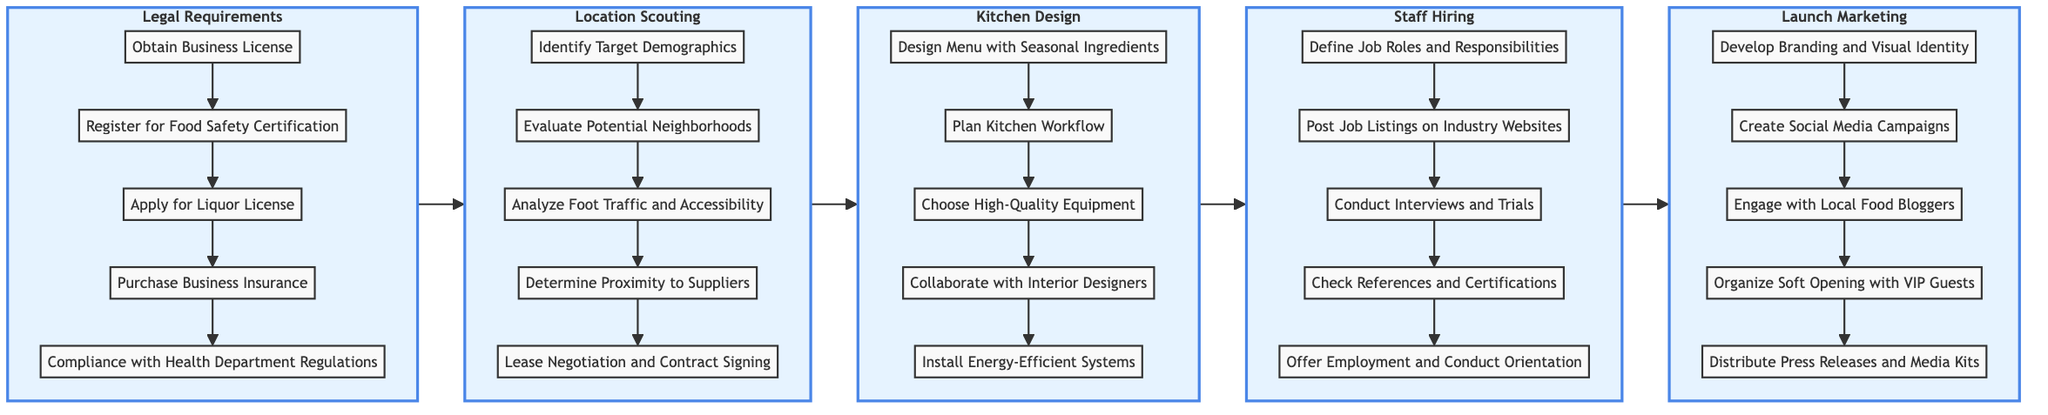What is the first step in the Legal Requirements section? The first step in the Legal Requirements section is "Obtain Business License". This can be verified by looking at the first node listed under the Legal Requirements subgraph.
Answer: Obtain Business License How many steps are there in the Kitchen Design section? In the Kitchen Design section, there are a total of five steps listed, counted directly from the nodes shown in the subgraph.
Answer: 5 Which step follows "Evaluate Potential Neighborhoods" in the Location Scouting section? The step that follows "Evaluate Potential Neighborhoods" is "Analyze Foot Traffic and Accessibility", which can be traced by looking at the flow from one node to the next in the Location Scouting subgraph.
Answer: Analyze Foot Traffic and Accessibility What is the last node in the Staff Hiring section? The last node in the Staff Hiring section is "Offer Employment and Conduct Orientation". This is identified as the final step listed in the vertical arrangement of the subgraph for Staff Hiring.
Answer: Offer Employment and Conduct Orientation Which section comes immediately after Kitchen Design? The section that comes immediately after Kitchen Design is Staff Hiring, as per the flow direction in the horizontal organization of the diagram's subgraphs.
Answer: Staff Hiring What are the key activities included in the Launch Marketing section? The key activities included in the Launch Marketing section are "Develop Branding and Visual Identity", "Create Social Media Campaigns", "Engage with Local Food Bloggers", "Organize Soft Opening with VIP Guests", and "Distribute Press Releases and Media Kits". These are the steps listed in that subgraph.
Answer: Develop Branding and Visual Identity, Create Social Media Campaigns, Engage with Local Food Bloggers, Organize Soft Opening with VIP Guests, Distribute Press Releases and Media Kits How does "Compliance with Health Department Regulations" relate to the other steps? "Compliance with Health Department Regulations" is the last step in the Legal Requirements section, indicating that it is a culmination of all prior legal activities required for opening, connecting it logically as a final requirement after obtaining licenses and certifications.
Answer: It is the last step in the Legal Requirements section Which section includes the step "Install Energy-Efficient Systems"? The step "Install Energy-Efficient Systems" is included in the Kitchen Design section. This can be determined by locating the specific step within the Kitchen Design subgraph.
Answer: Kitchen Design 